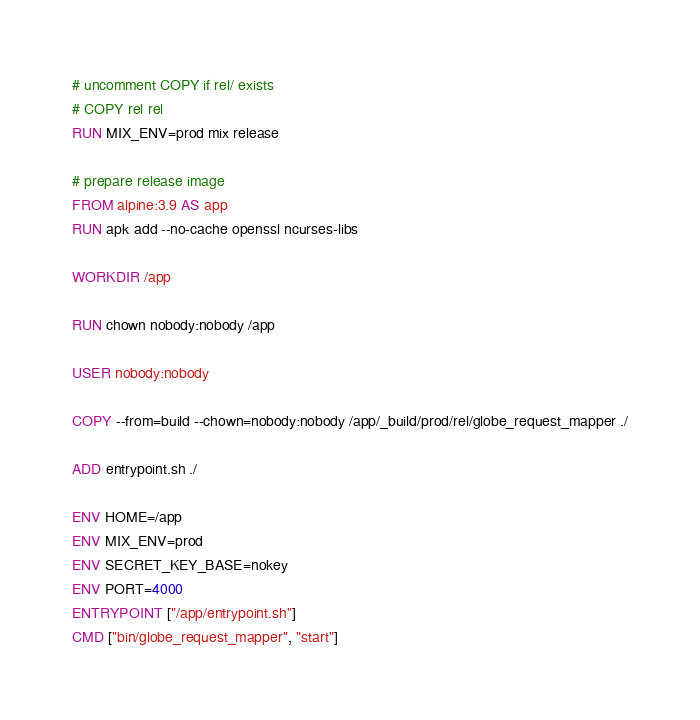<code> <loc_0><loc_0><loc_500><loc_500><_Dockerfile_># uncomment COPY if rel/ exists
# COPY rel rel
RUN MIX_ENV=prod mix release

# prepare release image
FROM alpine:3.9 AS app
RUN apk add --no-cache openssl ncurses-libs

WORKDIR /app

RUN chown nobody:nobody /app

USER nobody:nobody

COPY --from=build --chown=nobody:nobody /app/_build/prod/rel/globe_request_mapper ./

ADD entrypoint.sh ./

ENV HOME=/app
ENV MIX_ENV=prod
ENV SECRET_KEY_BASE=nokey
ENV PORT=4000
ENTRYPOINT ["/app/entrypoint.sh"]
CMD ["bin/globe_request_mapper", "start"]</code> 